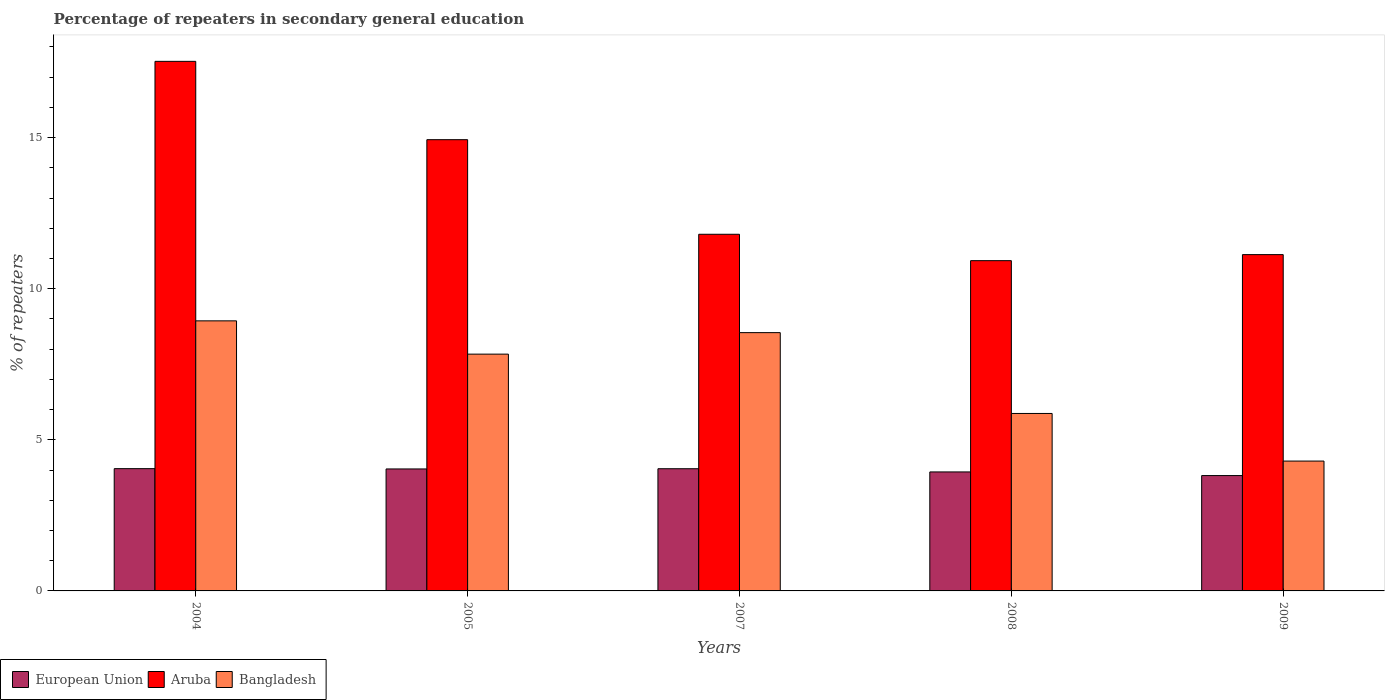How many different coloured bars are there?
Give a very brief answer. 3. How many groups of bars are there?
Ensure brevity in your answer.  5. Are the number of bars on each tick of the X-axis equal?
Your answer should be very brief. Yes. What is the label of the 5th group of bars from the left?
Your response must be concise. 2009. In how many cases, is the number of bars for a given year not equal to the number of legend labels?
Provide a short and direct response. 0. What is the percentage of repeaters in secondary general education in Aruba in 2004?
Your answer should be compact. 17.52. Across all years, what is the maximum percentage of repeaters in secondary general education in Bangladesh?
Ensure brevity in your answer.  8.94. Across all years, what is the minimum percentage of repeaters in secondary general education in Bangladesh?
Your response must be concise. 4.3. In which year was the percentage of repeaters in secondary general education in European Union maximum?
Give a very brief answer. 2004. In which year was the percentage of repeaters in secondary general education in European Union minimum?
Provide a succinct answer. 2009. What is the total percentage of repeaters in secondary general education in European Union in the graph?
Offer a terse response. 19.88. What is the difference between the percentage of repeaters in secondary general education in Aruba in 2005 and that in 2009?
Provide a short and direct response. 3.8. What is the difference between the percentage of repeaters in secondary general education in European Union in 2005 and the percentage of repeaters in secondary general education in Aruba in 2004?
Offer a very short reply. -13.49. What is the average percentage of repeaters in secondary general education in European Union per year?
Offer a terse response. 3.98. In the year 2008, what is the difference between the percentage of repeaters in secondary general education in European Union and percentage of repeaters in secondary general education in Bangladesh?
Offer a very short reply. -1.93. In how many years, is the percentage of repeaters in secondary general education in Bangladesh greater than 6 %?
Keep it short and to the point. 3. What is the ratio of the percentage of repeaters in secondary general education in Aruba in 2004 to that in 2008?
Your response must be concise. 1.6. Is the percentage of repeaters in secondary general education in European Union in 2007 less than that in 2009?
Provide a succinct answer. No. Is the difference between the percentage of repeaters in secondary general education in European Union in 2005 and 2009 greater than the difference between the percentage of repeaters in secondary general education in Bangladesh in 2005 and 2009?
Your response must be concise. No. What is the difference between the highest and the second highest percentage of repeaters in secondary general education in Aruba?
Keep it short and to the point. 2.59. What is the difference between the highest and the lowest percentage of repeaters in secondary general education in Bangladesh?
Give a very brief answer. 4.64. In how many years, is the percentage of repeaters in secondary general education in Bangladesh greater than the average percentage of repeaters in secondary general education in Bangladesh taken over all years?
Make the answer very short. 3. Is the sum of the percentage of repeaters in secondary general education in Bangladesh in 2004 and 2007 greater than the maximum percentage of repeaters in secondary general education in Aruba across all years?
Make the answer very short. No. What does the 2nd bar from the right in 2007 represents?
Ensure brevity in your answer.  Aruba. Are all the bars in the graph horizontal?
Give a very brief answer. No. How many years are there in the graph?
Your answer should be very brief. 5. Are the values on the major ticks of Y-axis written in scientific E-notation?
Provide a short and direct response. No. Does the graph contain any zero values?
Give a very brief answer. No. What is the title of the graph?
Offer a very short reply. Percentage of repeaters in secondary general education. What is the label or title of the X-axis?
Provide a short and direct response. Years. What is the label or title of the Y-axis?
Your response must be concise. % of repeaters. What is the % of repeaters in European Union in 2004?
Provide a short and direct response. 4.05. What is the % of repeaters in Aruba in 2004?
Your answer should be very brief. 17.52. What is the % of repeaters in Bangladesh in 2004?
Provide a short and direct response. 8.94. What is the % of repeaters in European Union in 2005?
Make the answer very short. 4.04. What is the % of repeaters of Aruba in 2005?
Offer a terse response. 14.93. What is the % of repeaters in Bangladesh in 2005?
Offer a very short reply. 7.83. What is the % of repeaters in European Union in 2007?
Offer a terse response. 4.04. What is the % of repeaters in Aruba in 2007?
Ensure brevity in your answer.  11.8. What is the % of repeaters in Bangladesh in 2007?
Offer a terse response. 8.55. What is the % of repeaters in European Union in 2008?
Give a very brief answer. 3.94. What is the % of repeaters of Aruba in 2008?
Offer a terse response. 10.93. What is the % of repeaters of Bangladesh in 2008?
Ensure brevity in your answer.  5.87. What is the % of repeaters in European Union in 2009?
Your response must be concise. 3.82. What is the % of repeaters in Aruba in 2009?
Give a very brief answer. 11.13. What is the % of repeaters of Bangladesh in 2009?
Keep it short and to the point. 4.3. Across all years, what is the maximum % of repeaters of European Union?
Ensure brevity in your answer.  4.05. Across all years, what is the maximum % of repeaters in Aruba?
Ensure brevity in your answer.  17.52. Across all years, what is the maximum % of repeaters in Bangladesh?
Give a very brief answer. 8.94. Across all years, what is the minimum % of repeaters in European Union?
Make the answer very short. 3.82. Across all years, what is the minimum % of repeaters of Aruba?
Your answer should be compact. 10.93. Across all years, what is the minimum % of repeaters of Bangladesh?
Your answer should be compact. 4.3. What is the total % of repeaters in European Union in the graph?
Keep it short and to the point. 19.88. What is the total % of repeaters of Aruba in the graph?
Your answer should be compact. 66.31. What is the total % of repeaters in Bangladesh in the graph?
Your response must be concise. 35.48. What is the difference between the % of repeaters in European Union in 2004 and that in 2005?
Ensure brevity in your answer.  0.01. What is the difference between the % of repeaters in Aruba in 2004 and that in 2005?
Give a very brief answer. 2.59. What is the difference between the % of repeaters of Bangladesh in 2004 and that in 2005?
Provide a short and direct response. 1.1. What is the difference between the % of repeaters in European Union in 2004 and that in 2007?
Make the answer very short. 0. What is the difference between the % of repeaters of Aruba in 2004 and that in 2007?
Your answer should be very brief. 5.72. What is the difference between the % of repeaters in Bangladesh in 2004 and that in 2007?
Offer a terse response. 0.39. What is the difference between the % of repeaters in European Union in 2004 and that in 2008?
Ensure brevity in your answer.  0.11. What is the difference between the % of repeaters in Aruba in 2004 and that in 2008?
Keep it short and to the point. 6.59. What is the difference between the % of repeaters of Bangladesh in 2004 and that in 2008?
Provide a succinct answer. 3.06. What is the difference between the % of repeaters of European Union in 2004 and that in 2009?
Make the answer very short. 0.23. What is the difference between the % of repeaters of Aruba in 2004 and that in 2009?
Provide a short and direct response. 6.39. What is the difference between the % of repeaters of Bangladesh in 2004 and that in 2009?
Your response must be concise. 4.64. What is the difference between the % of repeaters in European Union in 2005 and that in 2007?
Make the answer very short. -0.01. What is the difference between the % of repeaters of Aruba in 2005 and that in 2007?
Provide a succinct answer. 3.13. What is the difference between the % of repeaters in Bangladesh in 2005 and that in 2007?
Your answer should be very brief. -0.71. What is the difference between the % of repeaters of European Union in 2005 and that in 2008?
Make the answer very short. 0.1. What is the difference between the % of repeaters of Aruba in 2005 and that in 2008?
Keep it short and to the point. 4. What is the difference between the % of repeaters in Bangladesh in 2005 and that in 2008?
Give a very brief answer. 1.96. What is the difference between the % of repeaters in European Union in 2005 and that in 2009?
Your response must be concise. 0.22. What is the difference between the % of repeaters in Aruba in 2005 and that in 2009?
Provide a short and direct response. 3.8. What is the difference between the % of repeaters in Bangladesh in 2005 and that in 2009?
Make the answer very short. 3.54. What is the difference between the % of repeaters of European Union in 2007 and that in 2008?
Provide a short and direct response. 0.11. What is the difference between the % of repeaters in Aruba in 2007 and that in 2008?
Provide a short and direct response. 0.87. What is the difference between the % of repeaters of Bangladesh in 2007 and that in 2008?
Your answer should be compact. 2.67. What is the difference between the % of repeaters of European Union in 2007 and that in 2009?
Provide a short and direct response. 0.23. What is the difference between the % of repeaters of Aruba in 2007 and that in 2009?
Offer a very short reply. 0.67. What is the difference between the % of repeaters of Bangladesh in 2007 and that in 2009?
Offer a terse response. 4.25. What is the difference between the % of repeaters of European Union in 2008 and that in 2009?
Your response must be concise. 0.12. What is the difference between the % of repeaters of Aruba in 2008 and that in 2009?
Provide a short and direct response. -0.2. What is the difference between the % of repeaters of Bangladesh in 2008 and that in 2009?
Offer a terse response. 1.58. What is the difference between the % of repeaters of European Union in 2004 and the % of repeaters of Aruba in 2005?
Offer a terse response. -10.88. What is the difference between the % of repeaters of European Union in 2004 and the % of repeaters of Bangladesh in 2005?
Give a very brief answer. -3.79. What is the difference between the % of repeaters of Aruba in 2004 and the % of repeaters of Bangladesh in 2005?
Your answer should be compact. 9.69. What is the difference between the % of repeaters of European Union in 2004 and the % of repeaters of Aruba in 2007?
Offer a very short reply. -7.75. What is the difference between the % of repeaters in European Union in 2004 and the % of repeaters in Bangladesh in 2007?
Offer a very short reply. -4.5. What is the difference between the % of repeaters in Aruba in 2004 and the % of repeaters in Bangladesh in 2007?
Offer a very short reply. 8.98. What is the difference between the % of repeaters in European Union in 2004 and the % of repeaters in Aruba in 2008?
Offer a very short reply. -6.88. What is the difference between the % of repeaters of European Union in 2004 and the % of repeaters of Bangladesh in 2008?
Ensure brevity in your answer.  -1.83. What is the difference between the % of repeaters of Aruba in 2004 and the % of repeaters of Bangladesh in 2008?
Ensure brevity in your answer.  11.65. What is the difference between the % of repeaters of European Union in 2004 and the % of repeaters of Aruba in 2009?
Make the answer very short. -7.08. What is the difference between the % of repeaters in European Union in 2004 and the % of repeaters in Bangladesh in 2009?
Keep it short and to the point. -0.25. What is the difference between the % of repeaters of Aruba in 2004 and the % of repeaters of Bangladesh in 2009?
Ensure brevity in your answer.  13.23. What is the difference between the % of repeaters in European Union in 2005 and the % of repeaters in Aruba in 2007?
Make the answer very short. -7.76. What is the difference between the % of repeaters of European Union in 2005 and the % of repeaters of Bangladesh in 2007?
Keep it short and to the point. -4.51. What is the difference between the % of repeaters in Aruba in 2005 and the % of repeaters in Bangladesh in 2007?
Your answer should be compact. 6.38. What is the difference between the % of repeaters in European Union in 2005 and the % of repeaters in Aruba in 2008?
Keep it short and to the point. -6.89. What is the difference between the % of repeaters in European Union in 2005 and the % of repeaters in Bangladesh in 2008?
Give a very brief answer. -1.84. What is the difference between the % of repeaters in Aruba in 2005 and the % of repeaters in Bangladesh in 2008?
Provide a short and direct response. 9.06. What is the difference between the % of repeaters of European Union in 2005 and the % of repeaters of Aruba in 2009?
Your answer should be very brief. -7.09. What is the difference between the % of repeaters in European Union in 2005 and the % of repeaters in Bangladesh in 2009?
Provide a short and direct response. -0.26. What is the difference between the % of repeaters of Aruba in 2005 and the % of repeaters of Bangladesh in 2009?
Provide a short and direct response. 10.63. What is the difference between the % of repeaters of European Union in 2007 and the % of repeaters of Aruba in 2008?
Offer a terse response. -6.88. What is the difference between the % of repeaters in European Union in 2007 and the % of repeaters in Bangladesh in 2008?
Your answer should be very brief. -1.83. What is the difference between the % of repeaters in Aruba in 2007 and the % of repeaters in Bangladesh in 2008?
Keep it short and to the point. 5.93. What is the difference between the % of repeaters in European Union in 2007 and the % of repeaters in Aruba in 2009?
Provide a succinct answer. -7.08. What is the difference between the % of repeaters in European Union in 2007 and the % of repeaters in Bangladesh in 2009?
Provide a succinct answer. -0.25. What is the difference between the % of repeaters of Aruba in 2007 and the % of repeaters of Bangladesh in 2009?
Make the answer very short. 7.5. What is the difference between the % of repeaters of European Union in 2008 and the % of repeaters of Aruba in 2009?
Your answer should be compact. -7.19. What is the difference between the % of repeaters of European Union in 2008 and the % of repeaters of Bangladesh in 2009?
Your answer should be compact. -0.36. What is the difference between the % of repeaters in Aruba in 2008 and the % of repeaters in Bangladesh in 2009?
Your response must be concise. 6.63. What is the average % of repeaters of European Union per year?
Ensure brevity in your answer.  3.98. What is the average % of repeaters in Aruba per year?
Give a very brief answer. 13.26. What is the average % of repeaters of Bangladesh per year?
Ensure brevity in your answer.  7.1. In the year 2004, what is the difference between the % of repeaters of European Union and % of repeaters of Aruba?
Provide a succinct answer. -13.48. In the year 2004, what is the difference between the % of repeaters in European Union and % of repeaters in Bangladesh?
Your answer should be compact. -4.89. In the year 2004, what is the difference between the % of repeaters of Aruba and % of repeaters of Bangladesh?
Provide a succinct answer. 8.59. In the year 2005, what is the difference between the % of repeaters of European Union and % of repeaters of Aruba?
Your answer should be very brief. -10.89. In the year 2005, what is the difference between the % of repeaters of European Union and % of repeaters of Bangladesh?
Make the answer very short. -3.8. In the year 2005, what is the difference between the % of repeaters in Aruba and % of repeaters in Bangladesh?
Offer a terse response. 7.1. In the year 2007, what is the difference between the % of repeaters in European Union and % of repeaters in Aruba?
Offer a terse response. -7.76. In the year 2007, what is the difference between the % of repeaters in European Union and % of repeaters in Bangladesh?
Your answer should be compact. -4.5. In the year 2007, what is the difference between the % of repeaters in Aruba and % of repeaters in Bangladesh?
Your answer should be very brief. 3.25. In the year 2008, what is the difference between the % of repeaters in European Union and % of repeaters in Aruba?
Provide a succinct answer. -6.99. In the year 2008, what is the difference between the % of repeaters of European Union and % of repeaters of Bangladesh?
Offer a terse response. -1.93. In the year 2008, what is the difference between the % of repeaters of Aruba and % of repeaters of Bangladesh?
Provide a short and direct response. 5.06. In the year 2009, what is the difference between the % of repeaters in European Union and % of repeaters in Aruba?
Make the answer very short. -7.31. In the year 2009, what is the difference between the % of repeaters of European Union and % of repeaters of Bangladesh?
Your answer should be very brief. -0.48. In the year 2009, what is the difference between the % of repeaters of Aruba and % of repeaters of Bangladesh?
Keep it short and to the point. 6.83. What is the ratio of the % of repeaters in European Union in 2004 to that in 2005?
Offer a terse response. 1. What is the ratio of the % of repeaters of Aruba in 2004 to that in 2005?
Give a very brief answer. 1.17. What is the ratio of the % of repeaters in Bangladesh in 2004 to that in 2005?
Provide a short and direct response. 1.14. What is the ratio of the % of repeaters of European Union in 2004 to that in 2007?
Offer a terse response. 1. What is the ratio of the % of repeaters in Aruba in 2004 to that in 2007?
Your answer should be compact. 1.48. What is the ratio of the % of repeaters of Bangladesh in 2004 to that in 2007?
Provide a short and direct response. 1.05. What is the ratio of the % of repeaters in European Union in 2004 to that in 2008?
Keep it short and to the point. 1.03. What is the ratio of the % of repeaters in Aruba in 2004 to that in 2008?
Make the answer very short. 1.6. What is the ratio of the % of repeaters in Bangladesh in 2004 to that in 2008?
Make the answer very short. 1.52. What is the ratio of the % of repeaters in European Union in 2004 to that in 2009?
Give a very brief answer. 1.06. What is the ratio of the % of repeaters of Aruba in 2004 to that in 2009?
Your answer should be compact. 1.57. What is the ratio of the % of repeaters of Bangladesh in 2004 to that in 2009?
Give a very brief answer. 2.08. What is the ratio of the % of repeaters in European Union in 2005 to that in 2007?
Your answer should be compact. 1. What is the ratio of the % of repeaters in Aruba in 2005 to that in 2007?
Keep it short and to the point. 1.27. What is the ratio of the % of repeaters of Bangladesh in 2005 to that in 2007?
Keep it short and to the point. 0.92. What is the ratio of the % of repeaters of European Union in 2005 to that in 2008?
Keep it short and to the point. 1.03. What is the ratio of the % of repeaters in Aruba in 2005 to that in 2008?
Offer a very short reply. 1.37. What is the ratio of the % of repeaters in Bangladesh in 2005 to that in 2008?
Your answer should be compact. 1.33. What is the ratio of the % of repeaters in European Union in 2005 to that in 2009?
Offer a very short reply. 1.06. What is the ratio of the % of repeaters in Aruba in 2005 to that in 2009?
Provide a short and direct response. 1.34. What is the ratio of the % of repeaters of Bangladesh in 2005 to that in 2009?
Provide a succinct answer. 1.82. What is the ratio of the % of repeaters in European Union in 2007 to that in 2008?
Offer a very short reply. 1.03. What is the ratio of the % of repeaters of Aruba in 2007 to that in 2008?
Your answer should be very brief. 1.08. What is the ratio of the % of repeaters of Bangladesh in 2007 to that in 2008?
Keep it short and to the point. 1.46. What is the ratio of the % of repeaters in European Union in 2007 to that in 2009?
Ensure brevity in your answer.  1.06. What is the ratio of the % of repeaters of Aruba in 2007 to that in 2009?
Keep it short and to the point. 1.06. What is the ratio of the % of repeaters of Bangladesh in 2007 to that in 2009?
Your answer should be compact. 1.99. What is the ratio of the % of repeaters of European Union in 2008 to that in 2009?
Offer a terse response. 1.03. What is the ratio of the % of repeaters of Bangladesh in 2008 to that in 2009?
Keep it short and to the point. 1.37. What is the difference between the highest and the second highest % of repeaters in European Union?
Your answer should be compact. 0. What is the difference between the highest and the second highest % of repeaters of Aruba?
Offer a terse response. 2.59. What is the difference between the highest and the second highest % of repeaters in Bangladesh?
Give a very brief answer. 0.39. What is the difference between the highest and the lowest % of repeaters of European Union?
Provide a succinct answer. 0.23. What is the difference between the highest and the lowest % of repeaters of Aruba?
Make the answer very short. 6.59. What is the difference between the highest and the lowest % of repeaters of Bangladesh?
Your answer should be compact. 4.64. 